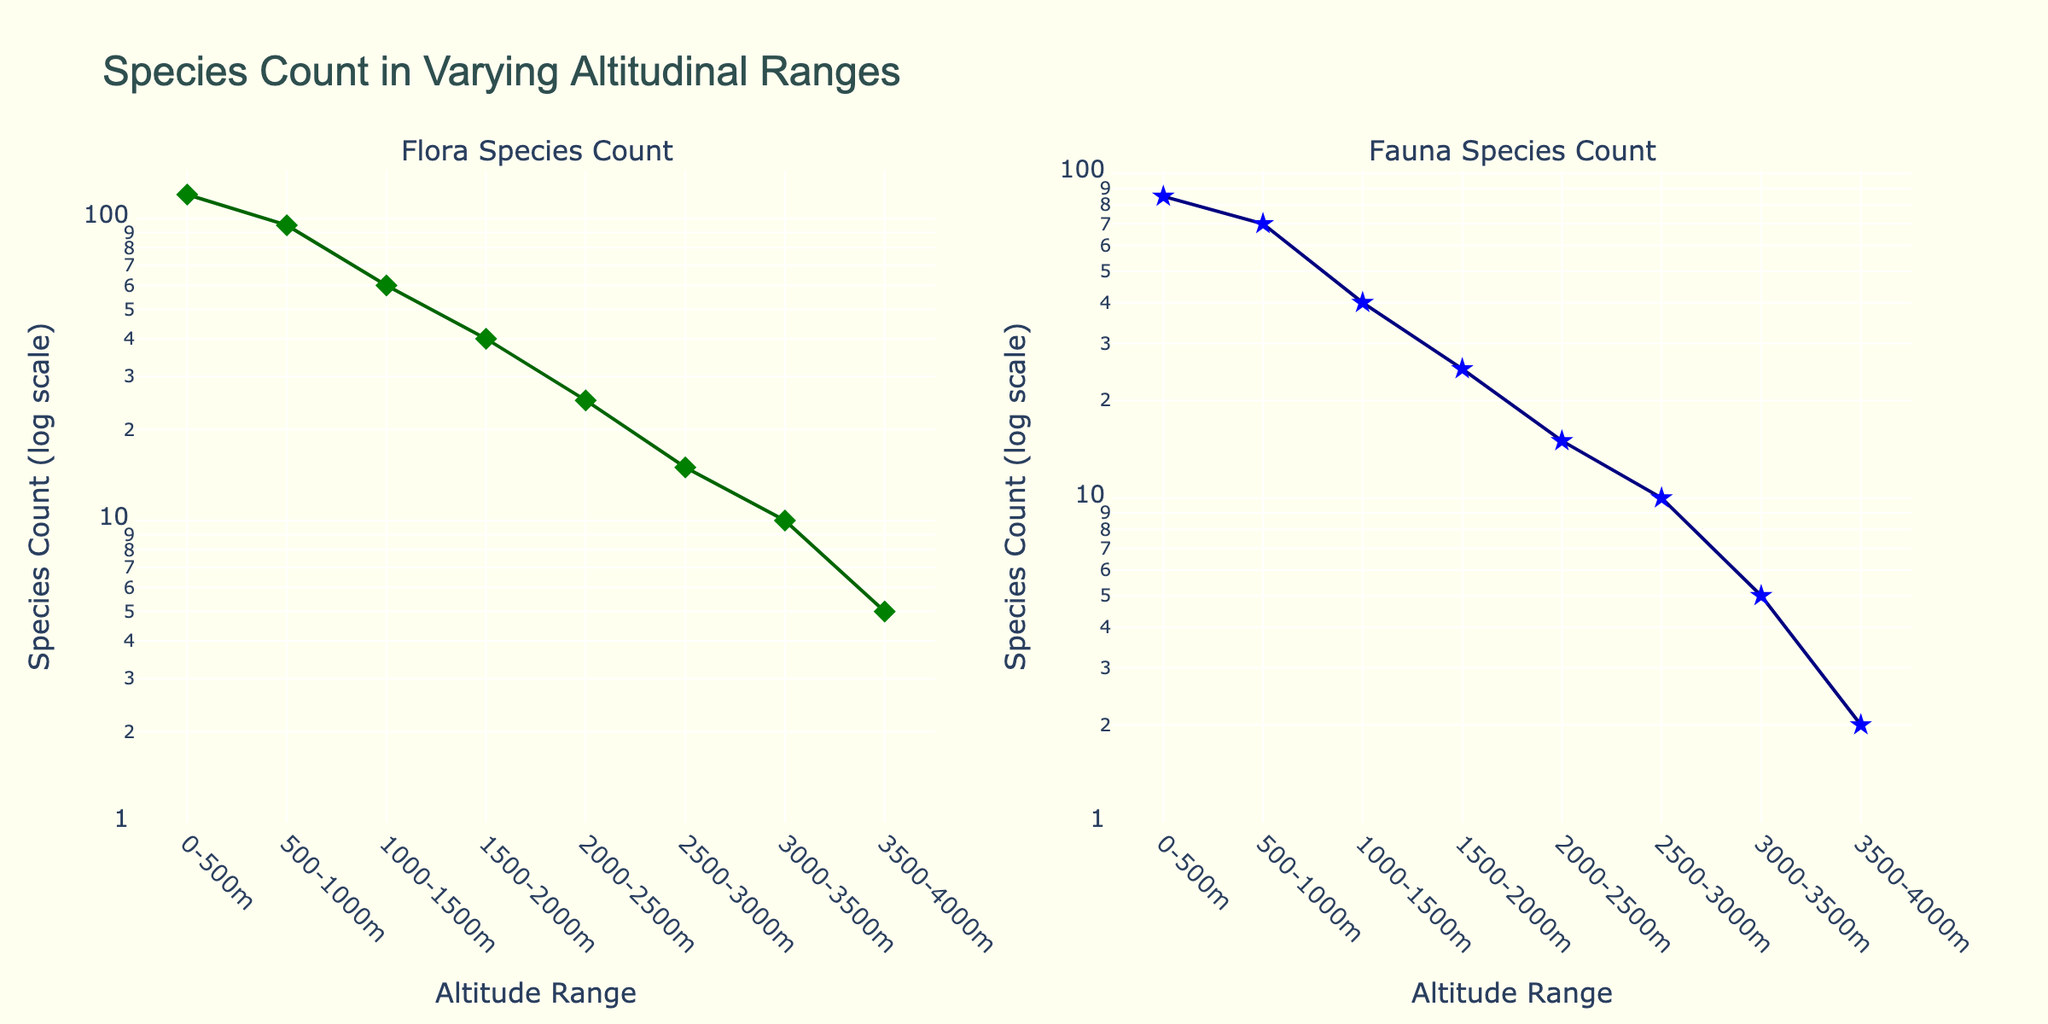What is the title of the figure? The title is displayed at the top center of the figure
Answer: Species Count in Varying Altitudinal Ranges How many altitude ranges are shown on the x-axis? The x-axis displays different altitude ranges, each marked as a distinct category. Counting these categories gives the number of altitude ranges
Answer: 8 What colors represent flora and fauna species counts? The scatter plot uses green to represent flora species count and blue to represent fauna species count
Answer: Green for flora, blue for fauna What is the highest flora species count and at which altitude range does it occur? The y-axis shows the species count on a log scale. The highest point on the flora species subplot is at “0-500m” with a flora species count of 120
Answer: 120 at 0-500m Which altitude range has the least fauna species count and what is the count? The lowest point on the fauna species subplot is at “3500-4000m” with a fauna species count of 2
Answer: 2 at 3500-4000m Compare the fauna species count at 1000-1500m and 2000-2500m. Which altitude range has more fauna species? The fauna species counts are plotted on a log scale. From the plots, “1000-1500m” has 40 fauna species, while “2000-2500m” has 15 fauna species. Therefore, 1000-1500m has more
Answer: 1000-1500m What is the trend in flora species count as altitude increases? Observing the flora species count subplot, the number of species decreases as the altitude range increases
Answer: Decreases How does the fauna species count at 1500-2000m compare to the flora species count at the same altitude? From the respective subplots, the fauna species count at 1500-2000m is 25, while the flora species count is 40. Therefore, flora species count is higher
Answer: Flora is higher (40 vs 25) Calculate the average flora species count for all altitude ranges. [Summing up the counts: 120+95+60+40+25+15+10+5 = 370. Dividing by 8 gives the average: 370/8 = 46.25]
Answer: 46.25 